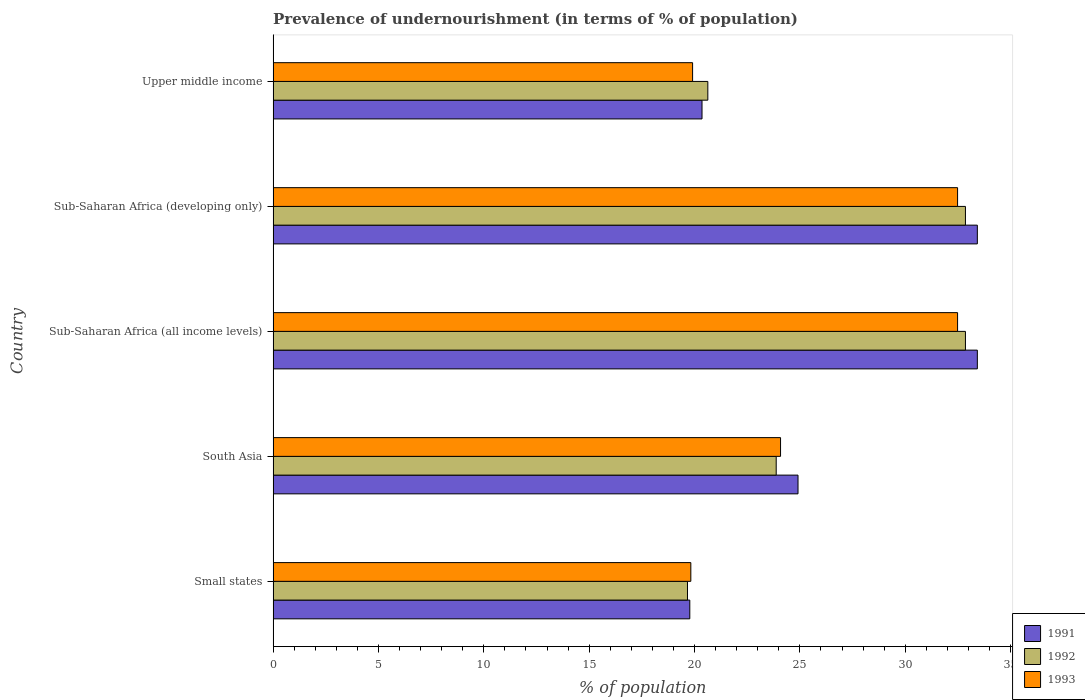How many groups of bars are there?
Provide a succinct answer. 5. How many bars are there on the 5th tick from the bottom?
Your answer should be very brief. 3. What is the label of the 3rd group of bars from the top?
Make the answer very short. Sub-Saharan Africa (all income levels). In how many cases, is the number of bars for a given country not equal to the number of legend labels?
Your answer should be very brief. 0. What is the percentage of undernourished population in 1992 in Sub-Saharan Africa (all income levels)?
Give a very brief answer. 32.86. Across all countries, what is the maximum percentage of undernourished population in 1993?
Your answer should be very brief. 32.48. Across all countries, what is the minimum percentage of undernourished population in 1991?
Your answer should be very brief. 19.77. In which country was the percentage of undernourished population in 1992 maximum?
Offer a terse response. Sub-Saharan Africa (all income levels). In which country was the percentage of undernourished population in 1992 minimum?
Give a very brief answer. Small states. What is the total percentage of undernourished population in 1993 in the graph?
Make the answer very short. 128.78. What is the difference between the percentage of undernourished population in 1993 in Small states and that in Sub-Saharan Africa (developing only)?
Offer a terse response. -12.66. What is the difference between the percentage of undernourished population in 1993 in Sub-Saharan Africa (all income levels) and the percentage of undernourished population in 1992 in South Asia?
Provide a succinct answer. 8.61. What is the average percentage of undernourished population in 1991 per country?
Your answer should be very brief. 26.38. What is the difference between the percentage of undernourished population in 1991 and percentage of undernourished population in 1992 in South Asia?
Ensure brevity in your answer.  1.04. In how many countries, is the percentage of undernourished population in 1993 greater than 9 %?
Make the answer very short. 5. What is the ratio of the percentage of undernourished population in 1993 in Small states to that in Sub-Saharan Africa (all income levels)?
Ensure brevity in your answer.  0.61. What is the difference between the highest and the second highest percentage of undernourished population in 1992?
Offer a terse response. 0. What is the difference between the highest and the lowest percentage of undernourished population in 1993?
Offer a very short reply. 12.66. What does the 2nd bar from the top in Sub-Saharan Africa (developing only) represents?
Provide a short and direct response. 1992. How many countries are there in the graph?
Provide a short and direct response. 5. What is the difference between two consecutive major ticks on the X-axis?
Provide a succinct answer. 5. How many legend labels are there?
Your answer should be very brief. 3. How are the legend labels stacked?
Give a very brief answer. Vertical. What is the title of the graph?
Your response must be concise. Prevalence of undernourishment (in terms of % of population). Does "1973" appear as one of the legend labels in the graph?
Your answer should be compact. No. What is the label or title of the X-axis?
Provide a short and direct response. % of population. What is the label or title of the Y-axis?
Make the answer very short. Country. What is the % of population in 1991 in Small states?
Your answer should be very brief. 19.77. What is the % of population in 1992 in Small states?
Provide a short and direct response. 19.66. What is the % of population in 1993 in Small states?
Make the answer very short. 19.82. What is the % of population of 1991 in South Asia?
Provide a succinct answer. 24.91. What is the % of population of 1992 in South Asia?
Keep it short and to the point. 23.88. What is the % of population in 1993 in South Asia?
Give a very brief answer. 24.08. What is the % of population of 1991 in Sub-Saharan Africa (all income levels)?
Keep it short and to the point. 33.42. What is the % of population of 1992 in Sub-Saharan Africa (all income levels)?
Provide a succinct answer. 32.86. What is the % of population in 1993 in Sub-Saharan Africa (all income levels)?
Your response must be concise. 32.48. What is the % of population in 1991 in Sub-Saharan Africa (developing only)?
Provide a short and direct response. 33.42. What is the % of population of 1992 in Sub-Saharan Africa (developing only)?
Your response must be concise. 32.86. What is the % of population of 1993 in Sub-Saharan Africa (developing only)?
Ensure brevity in your answer.  32.48. What is the % of population of 1991 in Upper middle income?
Keep it short and to the point. 20.35. What is the % of population of 1992 in Upper middle income?
Ensure brevity in your answer.  20.63. What is the % of population of 1993 in Upper middle income?
Give a very brief answer. 19.91. Across all countries, what is the maximum % of population in 1991?
Offer a terse response. 33.42. Across all countries, what is the maximum % of population of 1992?
Offer a terse response. 32.86. Across all countries, what is the maximum % of population of 1993?
Give a very brief answer. 32.48. Across all countries, what is the minimum % of population of 1991?
Provide a short and direct response. 19.77. Across all countries, what is the minimum % of population of 1992?
Your response must be concise. 19.66. Across all countries, what is the minimum % of population in 1993?
Ensure brevity in your answer.  19.82. What is the total % of population of 1991 in the graph?
Offer a very short reply. 131.88. What is the total % of population in 1992 in the graph?
Offer a very short reply. 129.88. What is the total % of population in 1993 in the graph?
Offer a terse response. 128.78. What is the difference between the % of population in 1991 in Small states and that in South Asia?
Offer a very short reply. -5.14. What is the difference between the % of population of 1992 in Small states and that in South Asia?
Provide a succinct answer. -4.21. What is the difference between the % of population of 1993 in Small states and that in South Asia?
Provide a short and direct response. -4.26. What is the difference between the % of population of 1991 in Small states and that in Sub-Saharan Africa (all income levels)?
Give a very brief answer. -13.65. What is the difference between the % of population of 1992 in Small states and that in Sub-Saharan Africa (all income levels)?
Ensure brevity in your answer.  -13.19. What is the difference between the % of population of 1993 in Small states and that in Sub-Saharan Africa (all income levels)?
Your response must be concise. -12.66. What is the difference between the % of population in 1991 in Small states and that in Sub-Saharan Africa (developing only)?
Your answer should be compact. -13.65. What is the difference between the % of population of 1992 in Small states and that in Sub-Saharan Africa (developing only)?
Ensure brevity in your answer.  -13.19. What is the difference between the % of population in 1993 in Small states and that in Sub-Saharan Africa (developing only)?
Provide a succinct answer. -12.66. What is the difference between the % of population in 1991 in Small states and that in Upper middle income?
Your answer should be very brief. -0.58. What is the difference between the % of population of 1992 in Small states and that in Upper middle income?
Offer a very short reply. -0.97. What is the difference between the % of population in 1993 in Small states and that in Upper middle income?
Your response must be concise. -0.08. What is the difference between the % of population in 1991 in South Asia and that in Sub-Saharan Africa (all income levels)?
Ensure brevity in your answer.  -8.51. What is the difference between the % of population of 1992 in South Asia and that in Sub-Saharan Africa (all income levels)?
Ensure brevity in your answer.  -8.98. What is the difference between the % of population of 1993 in South Asia and that in Sub-Saharan Africa (all income levels)?
Your response must be concise. -8.4. What is the difference between the % of population in 1991 in South Asia and that in Sub-Saharan Africa (developing only)?
Make the answer very short. -8.51. What is the difference between the % of population of 1992 in South Asia and that in Sub-Saharan Africa (developing only)?
Provide a succinct answer. -8.98. What is the difference between the % of population of 1993 in South Asia and that in Sub-Saharan Africa (developing only)?
Keep it short and to the point. -8.4. What is the difference between the % of population in 1991 in South Asia and that in Upper middle income?
Your answer should be compact. 4.56. What is the difference between the % of population in 1992 in South Asia and that in Upper middle income?
Give a very brief answer. 3.25. What is the difference between the % of population of 1993 in South Asia and that in Upper middle income?
Make the answer very short. 4.17. What is the difference between the % of population in 1992 in Sub-Saharan Africa (all income levels) and that in Sub-Saharan Africa (developing only)?
Provide a succinct answer. 0. What is the difference between the % of population in 1991 in Sub-Saharan Africa (all income levels) and that in Upper middle income?
Your answer should be compact. 13.07. What is the difference between the % of population of 1992 in Sub-Saharan Africa (all income levels) and that in Upper middle income?
Ensure brevity in your answer.  12.23. What is the difference between the % of population of 1993 in Sub-Saharan Africa (all income levels) and that in Upper middle income?
Your response must be concise. 12.58. What is the difference between the % of population of 1991 in Sub-Saharan Africa (developing only) and that in Upper middle income?
Provide a short and direct response. 13.07. What is the difference between the % of population of 1992 in Sub-Saharan Africa (developing only) and that in Upper middle income?
Ensure brevity in your answer.  12.23. What is the difference between the % of population of 1993 in Sub-Saharan Africa (developing only) and that in Upper middle income?
Provide a short and direct response. 12.58. What is the difference between the % of population of 1991 in Small states and the % of population of 1992 in South Asia?
Keep it short and to the point. -4.1. What is the difference between the % of population in 1991 in Small states and the % of population in 1993 in South Asia?
Your response must be concise. -4.31. What is the difference between the % of population in 1992 in Small states and the % of population in 1993 in South Asia?
Offer a terse response. -4.42. What is the difference between the % of population of 1991 in Small states and the % of population of 1992 in Sub-Saharan Africa (all income levels)?
Offer a terse response. -13.08. What is the difference between the % of population of 1991 in Small states and the % of population of 1993 in Sub-Saharan Africa (all income levels)?
Keep it short and to the point. -12.71. What is the difference between the % of population of 1992 in Small states and the % of population of 1993 in Sub-Saharan Africa (all income levels)?
Provide a short and direct response. -12.82. What is the difference between the % of population in 1991 in Small states and the % of population in 1992 in Sub-Saharan Africa (developing only)?
Your answer should be very brief. -13.08. What is the difference between the % of population in 1991 in Small states and the % of population in 1993 in Sub-Saharan Africa (developing only)?
Offer a terse response. -12.71. What is the difference between the % of population in 1992 in Small states and the % of population in 1993 in Sub-Saharan Africa (developing only)?
Give a very brief answer. -12.82. What is the difference between the % of population in 1991 in Small states and the % of population in 1992 in Upper middle income?
Keep it short and to the point. -0.86. What is the difference between the % of population of 1991 in Small states and the % of population of 1993 in Upper middle income?
Provide a succinct answer. -0.13. What is the difference between the % of population of 1992 in Small states and the % of population of 1993 in Upper middle income?
Your answer should be very brief. -0.24. What is the difference between the % of population in 1991 in South Asia and the % of population in 1992 in Sub-Saharan Africa (all income levels)?
Offer a terse response. -7.95. What is the difference between the % of population of 1991 in South Asia and the % of population of 1993 in Sub-Saharan Africa (all income levels)?
Make the answer very short. -7.57. What is the difference between the % of population of 1992 in South Asia and the % of population of 1993 in Sub-Saharan Africa (all income levels)?
Make the answer very short. -8.61. What is the difference between the % of population of 1991 in South Asia and the % of population of 1992 in Sub-Saharan Africa (developing only)?
Provide a short and direct response. -7.95. What is the difference between the % of population in 1991 in South Asia and the % of population in 1993 in Sub-Saharan Africa (developing only)?
Offer a terse response. -7.57. What is the difference between the % of population in 1992 in South Asia and the % of population in 1993 in Sub-Saharan Africa (developing only)?
Ensure brevity in your answer.  -8.61. What is the difference between the % of population of 1991 in South Asia and the % of population of 1992 in Upper middle income?
Your answer should be very brief. 4.28. What is the difference between the % of population in 1991 in South Asia and the % of population in 1993 in Upper middle income?
Provide a short and direct response. 5. What is the difference between the % of population in 1992 in South Asia and the % of population in 1993 in Upper middle income?
Your response must be concise. 3.97. What is the difference between the % of population in 1991 in Sub-Saharan Africa (all income levels) and the % of population in 1992 in Sub-Saharan Africa (developing only)?
Your answer should be compact. 0.57. What is the difference between the % of population in 1991 in Sub-Saharan Africa (all income levels) and the % of population in 1993 in Sub-Saharan Africa (developing only)?
Your response must be concise. 0.94. What is the difference between the % of population in 1992 in Sub-Saharan Africa (all income levels) and the % of population in 1993 in Sub-Saharan Africa (developing only)?
Ensure brevity in your answer.  0.37. What is the difference between the % of population in 1991 in Sub-Saharan Africa (all income levels) and the % of population in 1992 in Upper middle income?
Your answer should be compact. 12.79. What is the difference between the % of population of 1991 in Sub-Saharan Africa (all income levels) and the % of population of 1993 in Upper middle income?
Offer a terse response. 13.51. What is the difference between the % of population in 1992 in Sub-Saharan Africa (all income levels) and the % of population in 1993 in Upper middle income?
Make the answer very short. 12.95. What is the difference between the % of population in 1991 in Sub-Saharan Africa (developing only) and the % of population in 1992 in Upper middle income?
Offer a terse response. 12.79. What is the difference between the % of population of 1991 in Sub-Saharan Africa (developing only) and the % of population of 1993 in Upper middle income?
Ensure brevity in your answer.  13.51. What is the difference between the % of population of 1992 in Sub-Saharan Africa (developing only) and the % of population of 1993 in Upper middle income?
Make the answer very short. 12.95. What is the average % of population of 1991 per country?
Make the answer very short. 26.38. What is the average % of population of 1992 per country?
Your answer should be very brief. 25.98. What is the average % of population in 1993 per country?
Give a very brief answer. 25.76. What is the difference between the % of population of 1991 and % of population of 1992 in Small states?
Make the answer very short. 0.11. What is the difference between the % of population in 1991 and % of population in 1993 in Small states?
Provide a succinct answer. -0.05. What is the difference between the % of population of 1992 and % of population of 1993 in Small states?
Keep it short and to the point. -0.16. What is the difference between the % of population of 1991 and % of population of 1992 in South Asia?
Keep it short and to the point. 1.04. What is the difference between the % of population of 1991 and % of population of 1993 in South Asia?
Your answer should be very brief. 0.83. What is the difference between the % of population of 1992 and % of population of 1993 in South Asia?
Provide a short and direct response. -0.21. What is the difference between the % of population in 1991 and % of population in 1992 in Sub-Saharan Africa (all income levels)?
Ensure brevity in your answer.  0.57. What is the difference between the % of population of 1991 and % of population of 1993 in Sub-Saharan Africa (all income levels)?
Offer a terse response. 0.94. What is the difference between the % of population of 1992 and % of population of 1993 in Sub-Saharan Africa (all income levels)?
Offer a terse response. 0.37. What is the difference between the % of population of 1991 and % of population of 1992 in Sub-Saharan Africa (developing only)?
Your response must be concise. 0.57. What is the difference between the % of population in 1991 and % of population in 1993 in Sub-Saharan Africa (developing only)?
Ensure brevity in your answer.  0.94. What is the difference between the % of population of 1992 and % of population of 1993 in Sub-Saharan Africa (developing only)?
Keep it short and to the point. 0.37. What is the difference between the % of population of 1991 and % of population of 1992 in Upper middle income?
Offer a very short reply. -0.28. What is the difference between the % of population in 1991 and % of population in 1993 in Upper middle income?
Your response must be concise. 0.45. What is the difference between the % of population of 1992 and % of population of 1993 in Upper middle income?
Offer a terse response. 0.72. What is the ratio of the % of population of 1991 in Small states to that in South Asia?
Keep it short and to the point. 0.79. What is the ratio of the % of population in 1992 in Small states to that in South Asia?
Provide a succinct answer. 0.82. What is the ratio of the % of population of 1993 in Small states to that in South Asia?
Offer a terse response. 0.82. What is the ratio of the % of population in 1991 in Small states to that in Sub-Saharan Africa (all income levels)?
Your answer should be compact. 0.59. What is the ratio of the % of population in 1992 in Small states to that in Sub-Saharan Africa (all income levels)?
Ensure brevity in your answer.  0.6. What is the ratio of the % of population in 1993 in Small states to that in Sub-Saharan Africa (all income levels)?
Give a very brief answer. 0.61. What is the ratio of the % of population of 1991 in Small states to that in Sub-Saharan Africa (developing only)?
Keep it short and to the point. 0.59. What is the ratio of the % of population of 1992 in Small states to that in Sub-Saharan Africa (developing only)?
Give a very brief answer. 0.6. What is the ratio of the % of population in 1993 in Small states to that in Sub-Saharan Africa (developing only)?
Give a very brief answer. 0.61. What is the ratio of the % of population of 1991 in Small states to that in Upper middle income?
Your answer should be very brief. 0.97. What is the ratio of the % of population in 1992 in Small states to that in Upper middle income?
Your answer should be compact. 0.95. What is the ratio of the % of population of 1991 in South Asia to that in Sub-Saharan Africa (all income levels)?
Offer a very short reply. 0.75. What is the ratio of the % of population in 1992 in South Asia to that in Sub-Saharan Africa (all income levels)?
Keep it short and to the point. 0.73. What is the ratio of the % of population in 1993 in South Asia to that in Sub-Saharan Africa (all income levels)?
Provide a short and direct response. 0.74. What is the ratio of the % of population of 1991 in South Asia to that in Sub-Saharan Africa (developing only)?
Give a very brief answer. 0.75. What is the ratio of the % of population in 1992 in South Asia to that in Sub-Saharan Africa (developing only)?
Your response must be concise. 0.73. What is the ratio of the % of population in 1993 in South Asia to that in Sub-Saharan Africa (developing only)?
Offer a very short reply. 0.74. What is the ratio of the % of population of 1991 in South Asia to that in Upper middle income?
Ensure brevity in your answer.  1.22. What is the ratio of the % of population of 1992 in South Asia to that in Upper middle income?
Ensure brevity in your answer.  1.16. What is the ratio of the % of population of 1993 in South Asia to that in Upper middle income?
Provide a short and direct response. 1.21. What is the ratio of the % of population of 1992 in Sub-Saharan Africa (all income levels) to that in Sub-Saharan Africa (developing only)?
Ensure brevity in your answer.  1. What is the ratio of the % of population of 1993 in Sub-Saharan Africa (all income levels) to that in Sub-Saharan Africa (developing only)?
Offer a terse response. 1. What is the ratio of the % of population of 1991 in Sub-Saharan Africa (all income levels) to that in Upper middle income?
Your answer should be compact. 1.64. What is the ratio of the % of population of 1992 in Sub-Saharan Africa (all income levels) to that in Upper middle income?
Offer a terse response. 1.59. What is the ratio of the % of population in 1993 in Sub-Saharan Africa (all income levels) to that in Upper middle income?
Your answer should be very brief. 1.63. What is the ratio of the % of population of 1991 in Sub-Saharan Africa (developing only) to that in Upper middle income?
Keep it short and to the point. 1.64. What is the ratio of the % of population of 1992 in Sub-Saharan Africa (developing only) to that in Upper middle income?
Your response must be concise. 1.59. What is the ratio of the % of population in 1993 in Sub-Saharan Africa (developing only) to that in Upper middle income?
Provide a succinct answer. 1.63. What is the difference between the highest and the lowest % of population in 1991?
Your answer should be compact. 13.65. What is the difference between the highest and the lowest % of population of 1992?
Your response must be concise. 13.19. What is the difference between the highest and the lowest % of population of 1993?
Keep it short and to the point. 12.66. 